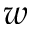<formula> <loc_0><loc_0><loc_500><loc_500>w</formula> 